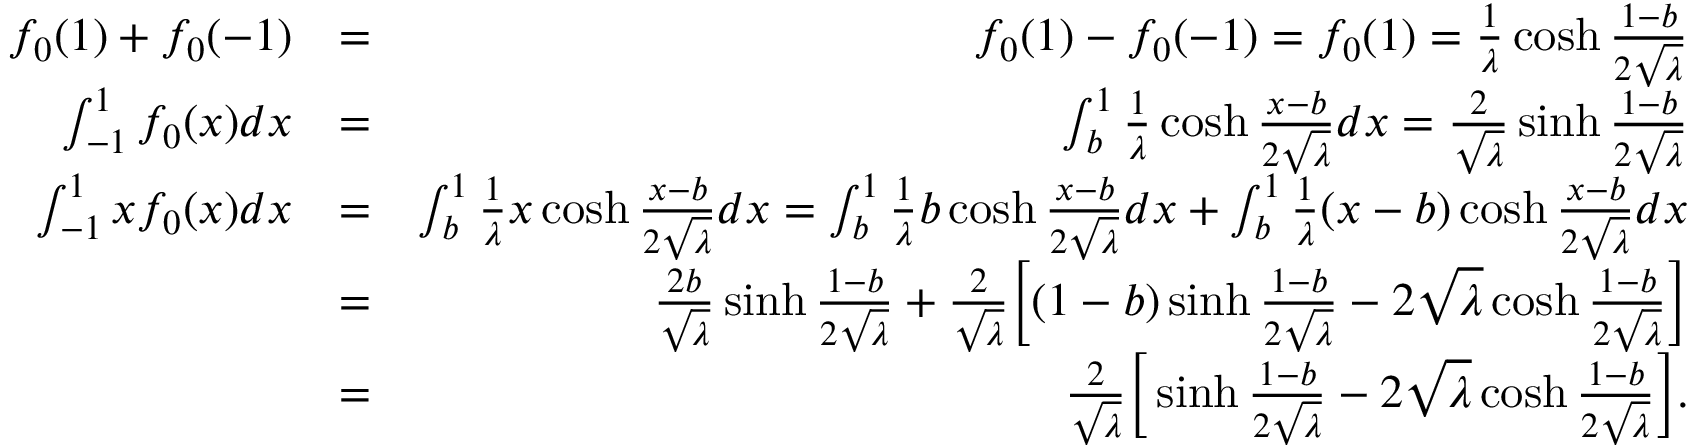<formula> <loc_0><loc_0><loc_500><loc_500>\begin{array} { r l r } { f _ { 0 } ( 1 ) + f _ { 0 } ( - 1 ) } & { = } & { f _ { 0 } ( 1 ) - f _ { 0 } ( - 1 ) = f _ { 0 } ( 1 ) = \frac { 1 } { \lambda } \cosh \frac { 1 - b } { 2 \sqrt { \lambda } } } \\ { \int _ { - 1 } ^ { 1 } f _ { 0 } ( x ) d x } & { = } & { \int _ { b } ^ { 1 } \frac { 1 } { \lambda } \cosh \frac { x - b } { 2 \sqrt { \lambda } } d x = \frac { 2 } { \sqrt { \lambda } } \sinh \frac { 1 - b } { 2 \sqrt { \lambda } } } \\ { \int _ { - 1 } ^ { 1 } x f _ { 0 } ( x ) d x } & { = } & { \int _ { b } ^ { 1 } \frac { 1 } { \lambda } x \cosh \frac { x - b } { 2 \sqrt { \lambda } } d x = \int _ { b } ^ { 1 } \frac { 1 } { \lambda } b \cosh \frac { x - b } { 2 \sqrt { \lambda } } d x + \int _ { b } ^ { 1 } \frac { 1 } { \lambda } ( x - b ) \cosh \frac { x - b } { 2 \sqrt { \lambda } } d x } \\ & { = } & { \frac { 2 b } { \sqrt { \lambda } } \sinh \frac { 1 - b } { 2 \sqrt { \lambda } } + \frac { 2 } { \sqrt { \lambda } } \left [ ( 1 - b ) \sinh \frac { 1 - b } { 2 \sqrt { \lambda } } - 2 \sqrt { \lambda } \cosh \frac { 1 - b } { 2 \sqrt { \lambda } } \right ] } \\ & { = } & { \frac { 2 } { \sqrt { \lambda } } \left [ \sinh \frac { 1 - b } { 2 \sqrt { \lambda } } - 2 \sqrt { \lambda } \cosh \frac { 1 - b } { 2 \sqrt { \lambda } } \right ] . } \end{array}</formula> 